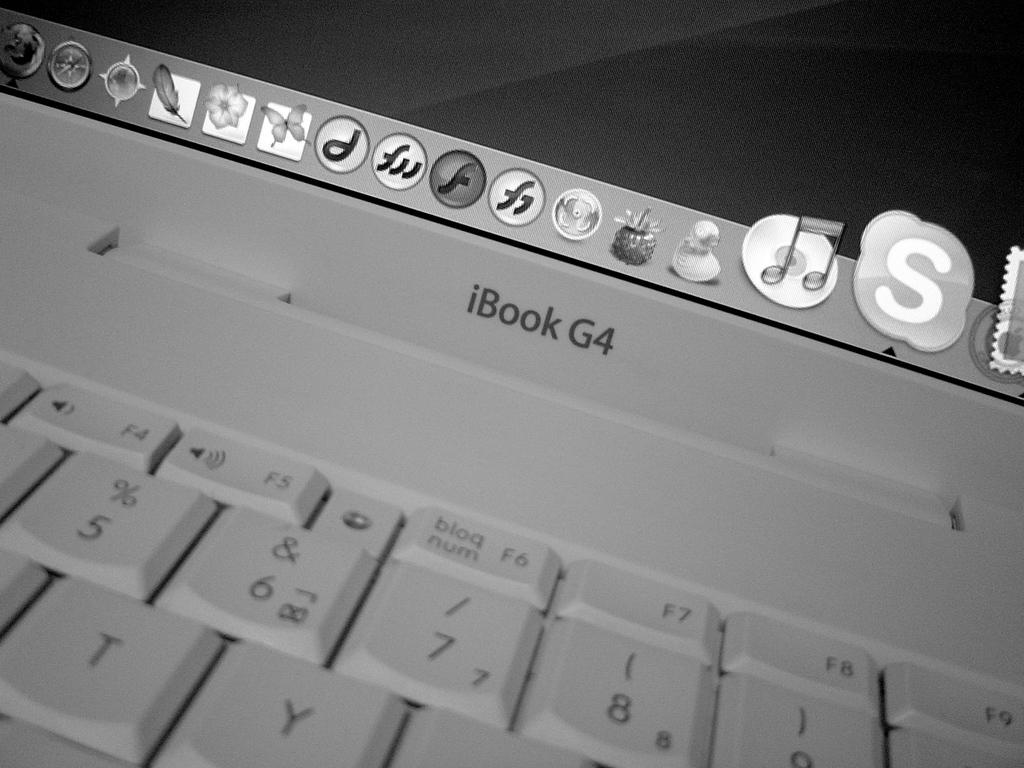What laptop is this?
Ensure brevity in your answer.  Ibook g4. What model laptop?
Your response must be concise. Ibook g4. 